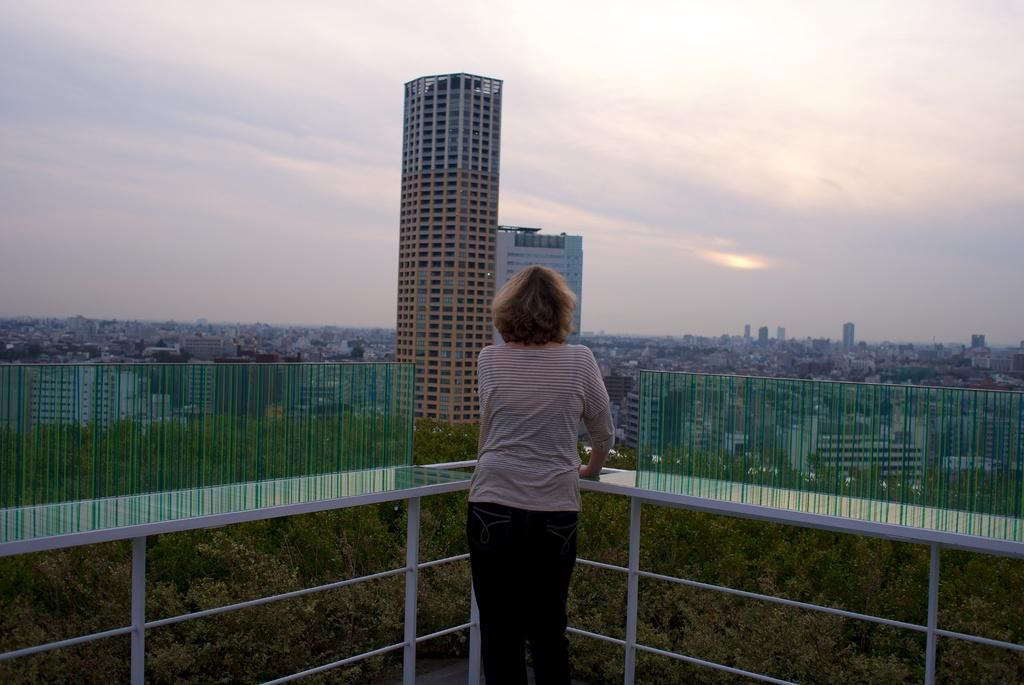What is the main subject of the image? There is a woman standing in the image. What is the woman holding in the image? The woman is holding grills in the image. What type of structures can be seen in the image? There are buildings, including skyscrapers, in the image. What type of vegetation is present in the image? There are trees in the image. What is visible in the background of the image? The sky is visible in the image, and there are clouds present in the sky. Can you describe the effect of the snake on the woman in the image? There is no snake present in the image, so it is not possible to describe any effect on the woman. 